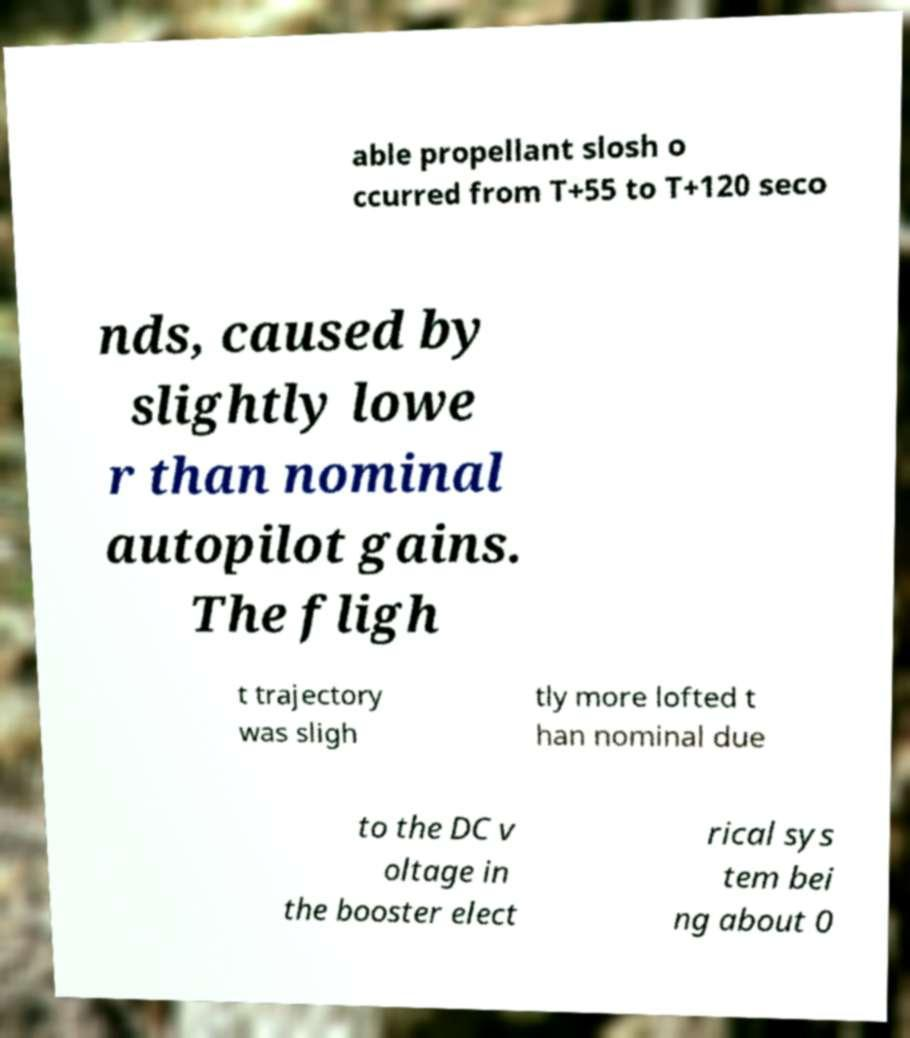Could you extract and type out the text from this image? able propellant slosh o ccurred from T+55 to T+120 seco nds, caused by slightly lowe r than nominal autopilot gains. The fligh t trajectory was sligh tly more lofted t han nominal due to the DC v oltage in the booster elect rical sys tem bei ng about 0 